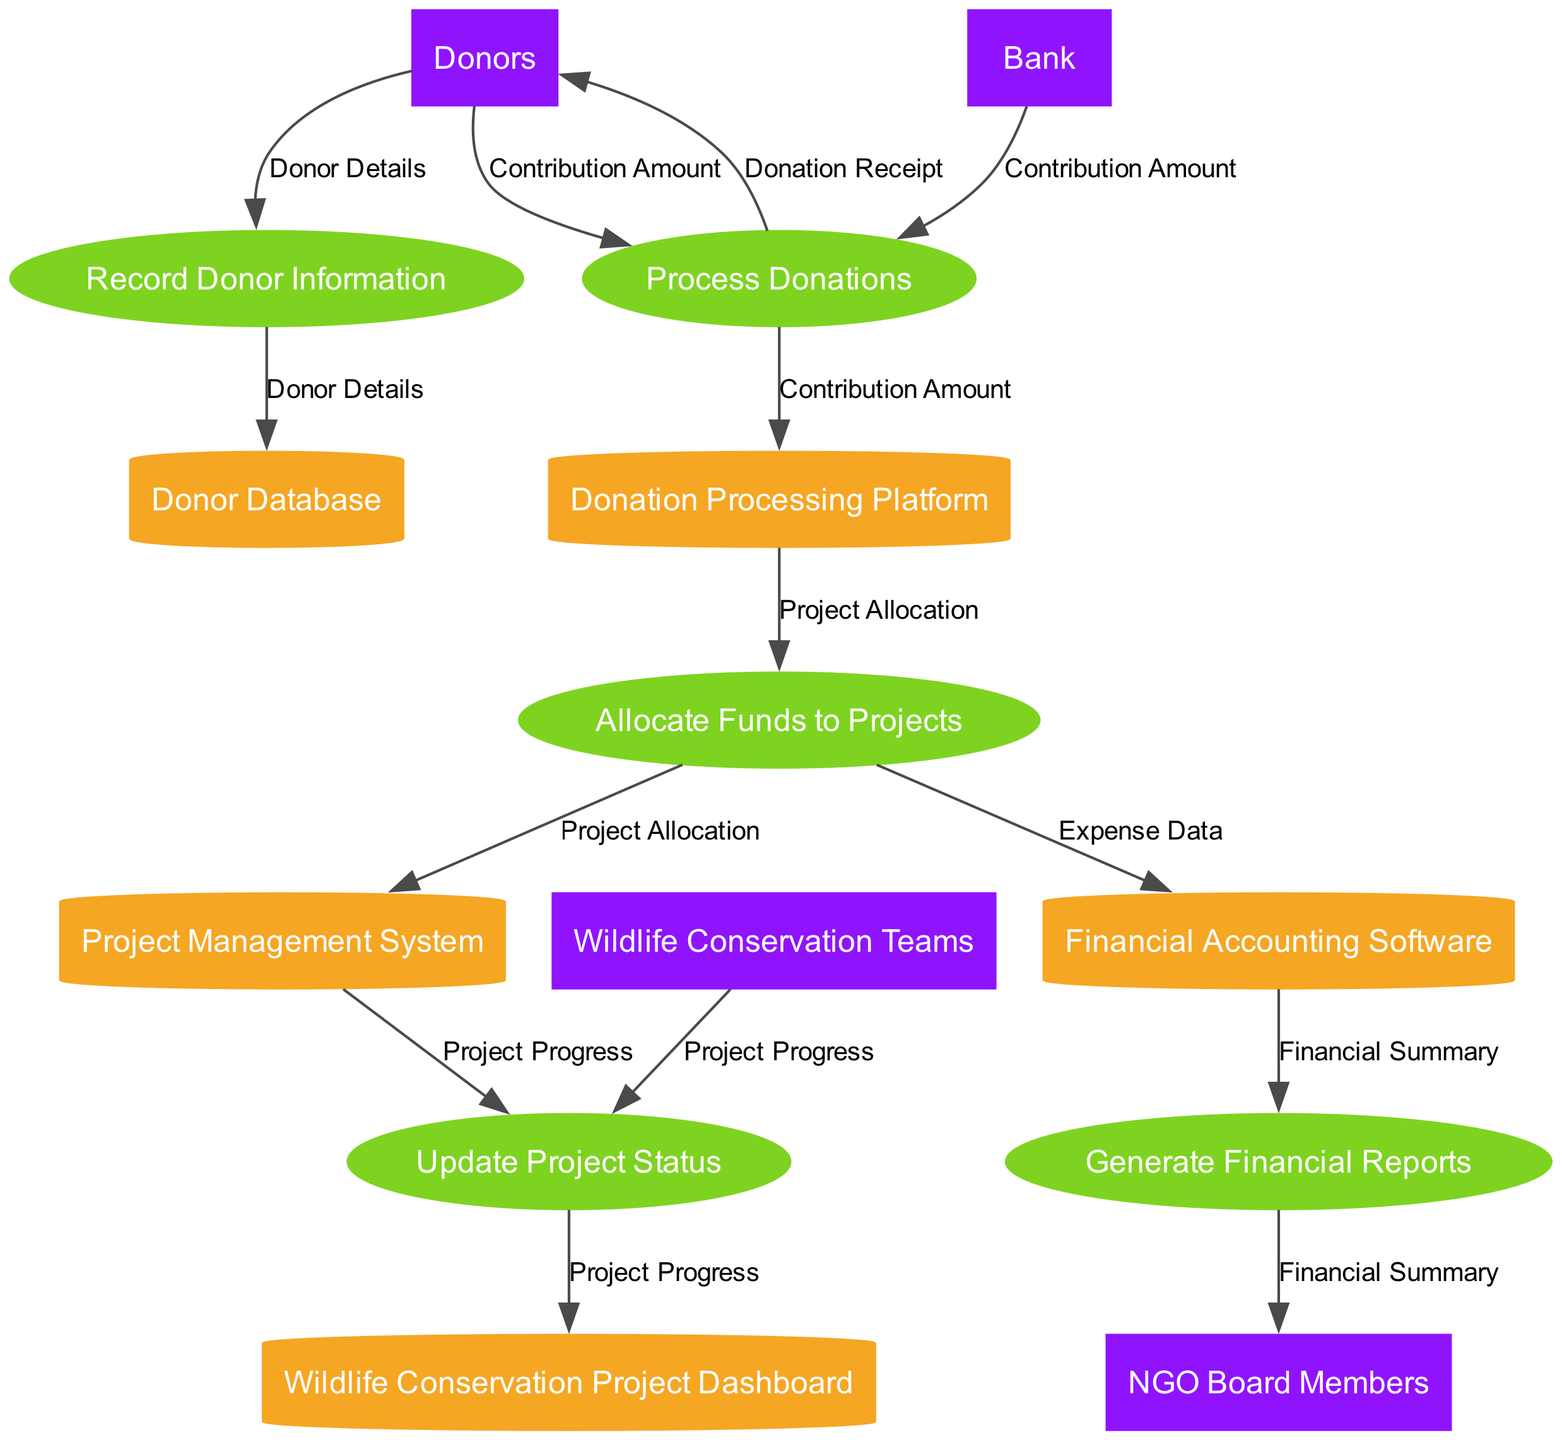What is the total number of entities in the diagram? The diagram contains five entities: Donor Database, Project Management System, Financial Accounting Software, Donation Processing Platform, and Wildlife Conservation Project Dashboard. Therefore, the total number of entities is five.
Answer: five Which process receives data from the Donors? The "Process Donations" process receives data labeled "Contribution Amount" from the Donors. We can see this connection between the Donors and the Process Donations node in the diagram.
Answer: Process Donations How many external entities are present in the diagram? The diagram includes four external entities: Donors, Bank, Wildlife Conservation Teams, and NGO Board Members. By counting these, we establish that there are four external entities.
Answer: four What data flow is linked to the "Generate Financial Reports" process? The "Generate Financial Reports" process is connected to the "Financial Summary" data flow. We can see that the Financial Accounting Software contributes this data flow to the Generate Financial Reports node.
Answer: Financial Summary Which entity is responsible for managing project status updates? The "Project Management System" is responsible for managing project status updates, as indicated by the flow from "Update Project Status" to the Project Management System in the diagram.
Answer: Project Management System Which process is the final step before data is reported to the NGO Board Members? The final process before reporting to the NGO Board Members is "Generate Financial Reports." This is derived from the flow that leads directly to the NGO Board Members from this process.
Answer: Generate Financial Reports What is the connection between "Donation Processing Platform" and "Allocate Funds to Projects"? The "Donation Processing Platform" sends the data flow labeled "Project Allocation" to the "Allocate Funds to Projects" process, indicating that it allocates funds based on donations processed.
Answer: Project Allocation How many data flows are depicted in the diagram? The diagram contains six data flows: Donor Details, Contribution Amount, Project Allocation, Expense Data, Project Progress, and Financial Summary. Counting these flows, we find there are six data flows shown.
Answer: six Which external entity interacts with the "Process Donations" process? The "Bank" is the external entity that interacts with the "Process Donations" process by providing the "Contribution Amount" data flow, as indicated in the diagram's relationships.
Answer: Bank 